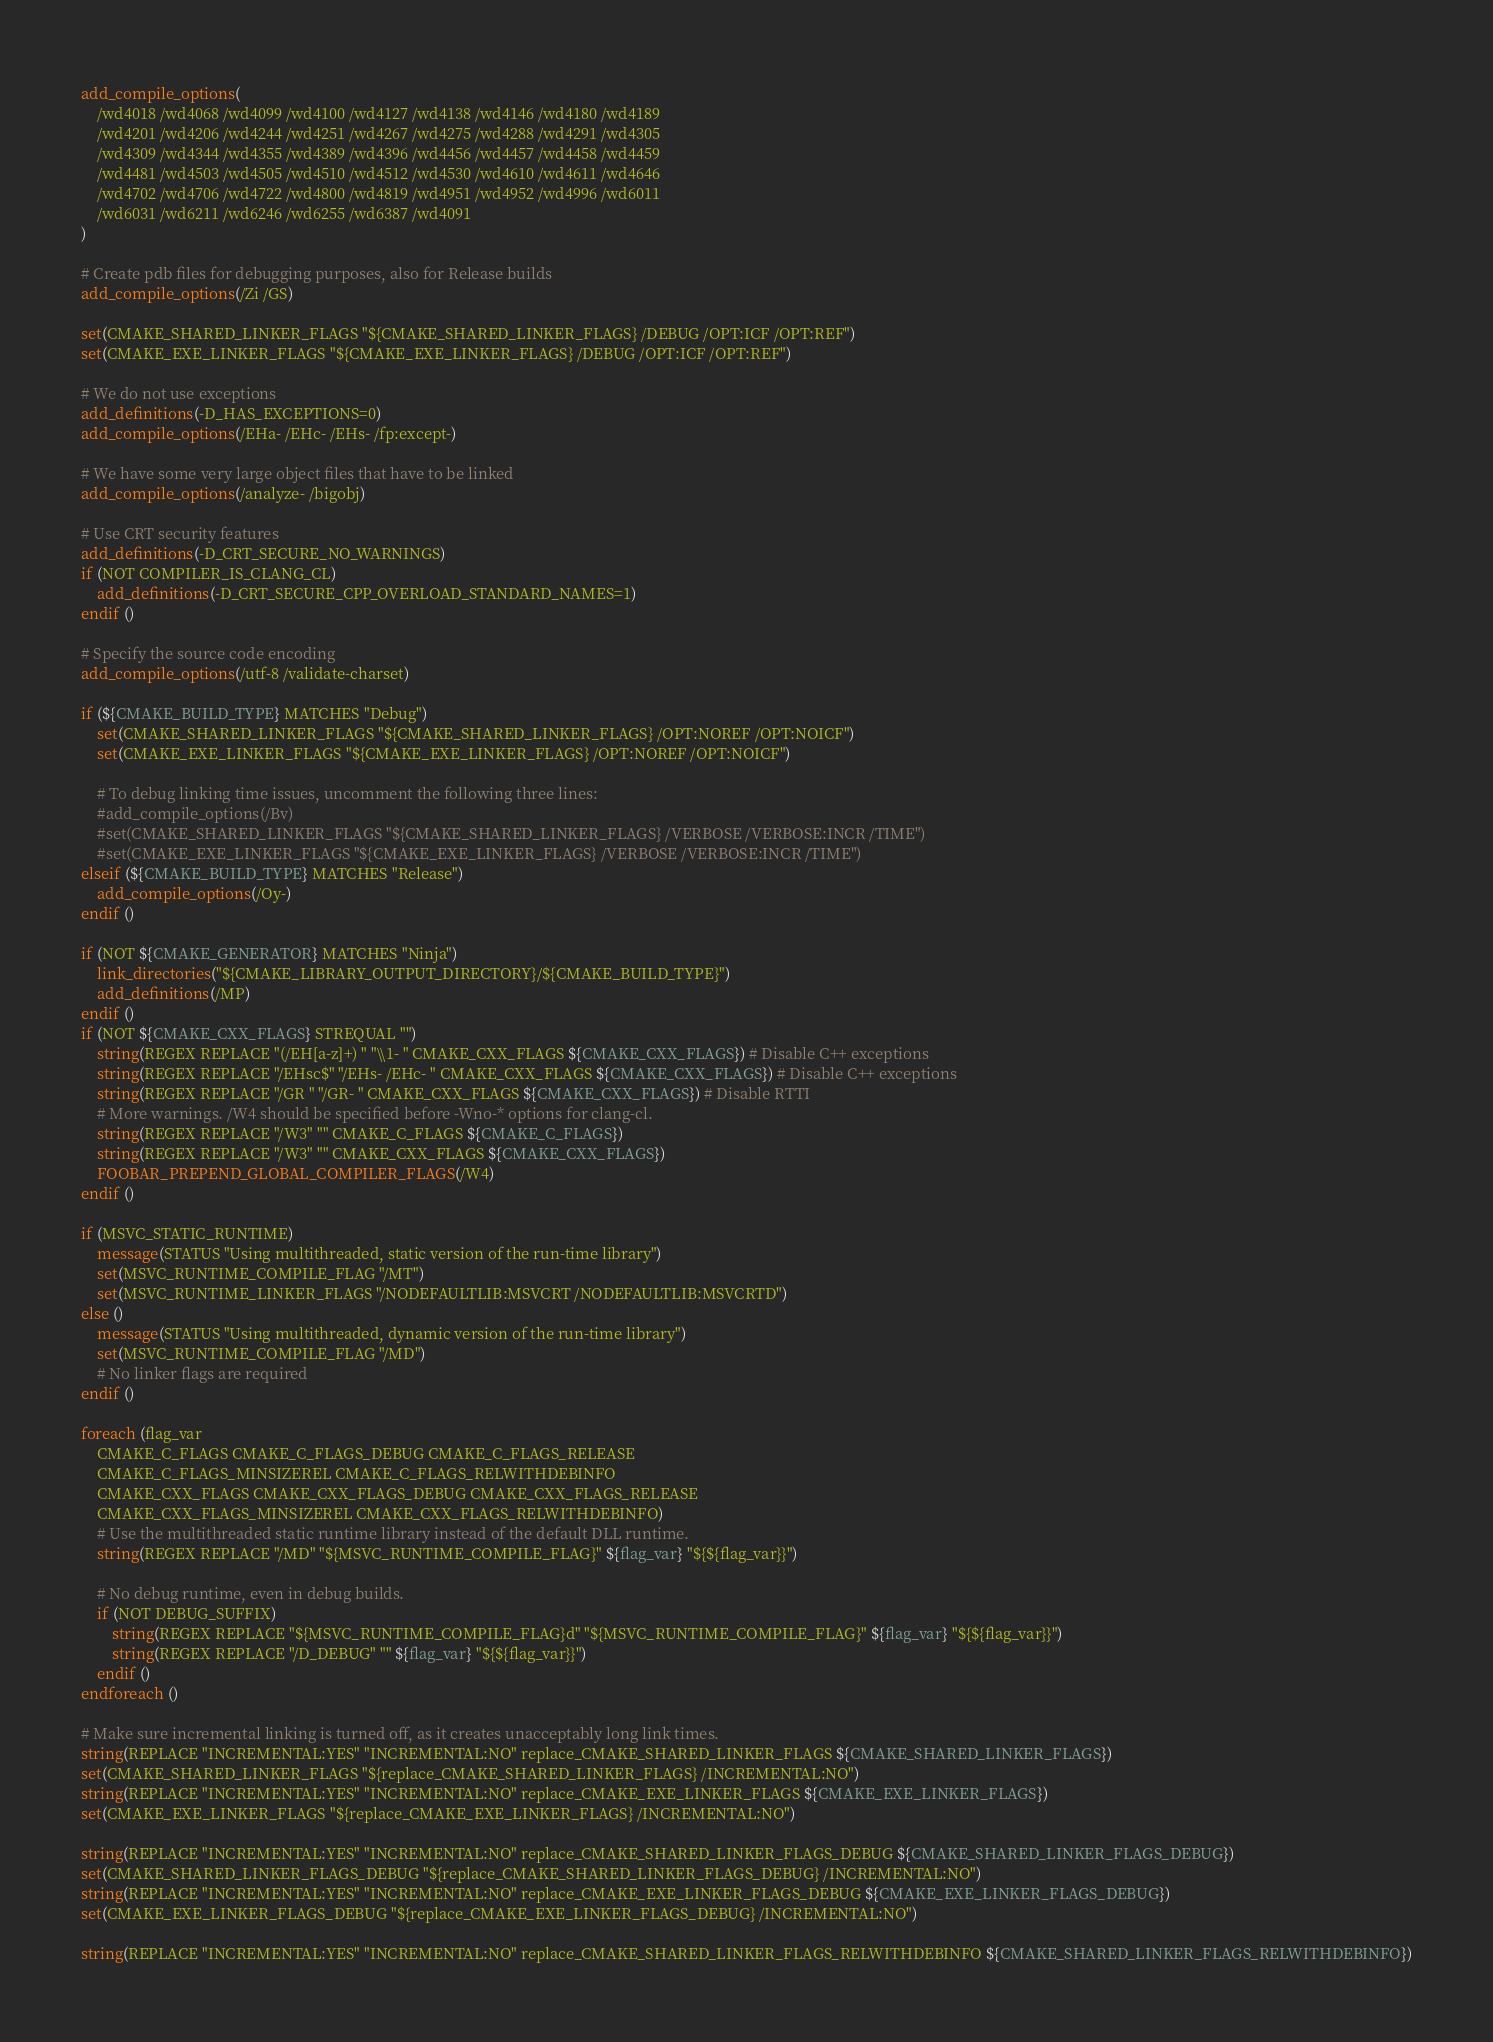Convert code to text. <code><loc_0><loc_0><loc_500><loc_500><_CMake_>add_compile_options(
    /wd4018 /wd4068 /wd4099 /wd4100 /wd4127 /wd4138 /wd4146 /wd4180 /wd4189
    /wd4201 /wd4206 /wd4244 /wd4251 /wd4267 /wd4275 /wd4288 /wd4291 /wd4305
    /wd4309 /wd4344 /wd4355 /wd4389 /wd4396 /wd4456 /wd4457 /wd4458 /wd4459
    /wd4481 /wd4503 /wd4505 /wd4510 /wd4512 /wd4530 /wd4610 /wd4611 /wd4646
    /wd4702 /wd4706 /wd4722 /wd4800 /wd4819 /wd4951 /wd4952 /wd4996 /wd6011
    /wd6031 /wd6211 /wd6246 /wd6255 /wd6387 /wd4091
)

# Create pdb files for debugging purposes, also for Release builds
add_compile_options(/Zi /GS)

set(CMAKE_SHARED_LINKER_FLAGS "${CMAKE_SHARED_LINKER_FLAGS} /DEBUG /OPT:ICF /OPT:REF")
set(CMAKE_EXE_LINKER_FLAGS "${CMAKE_EXE_LINKER_FLAGS} /DEBUG /OPT:ICF /OPT:REF")

# We do not use exceptions
add_definitions(-D_HAS_EXCEPTIONS=0)
add_compile_options(/EHa- /EHc- /EHs- /fp:except-)

# We have some very large object files that have to be linked
add_compile_options(/analyze- /bigobj)

# Use CRT security features
add_definitions(-D_CRT_SECURE_NO_WARNINGS)
if (NOT COMPILER_IS_CLANG_CL)
    add_definitions(-D_CRT_SECURE_CPP_OVERLOAD_STANDARD_NAMES=1)
endif ()

# Specify the source code encoding
add_compile_options(/utf-8 /validate-charset)

if (${CMAKE_BUILD_TYPE} MATCHES "Debug")
    set(CMAKE_SHARED_LINKER_FLAGS "${CMAKE_SHARED_LINKER_FLAGS} /OPT:NOREF /OPT:NOICF")
    set(CMAKE_EXE_LINKER_FLAGS "${CMAKE_EXE_LINKER_FLAGS} /OPT:NOREF /OPT:NOICF")

    # To debug linking time issues, uncomment the following three lines:
    #add_compile_options(/Bv)
    #set(CMAKE_SHARED_LINKER_FLAGS "${CMAKE_SHARED_LINKER_FLAGS} /VERBOSE /VERBOSE:INCR /TIME")
    #set(CMAKE_EXE_LINKER_FLAGS "${CMAKE_EXE_LINKER_FLAGS} /VERBOSE /VERBOSE:INCR /TIME")
elseif (${CMAKE_BUILD_TYPE} MATCHES "Release")
    add_compile_options(/Oy-)
endif ()

if (NOT ${CMAKE_GENERATOR} MATCHES "Ninja")
    link_directories("${CMAKE_LIBRARY_OUTPUT_DIRECTORY}/${CMAKE_BUILD_TYPE}")
    add_definitions(/MP)
endif ()
if (NOT ${CMAKE_CXX_FLAGS} STREQUAL "")
    string(REGEX REPLACE "(/EH[a-z]+) " "\\1- " CMAKE_CXX_FLAGS ${CMAKE_CXX_FLAGS}) # Disable C++ exceptions
    string(REGEX REPLACE "/EHsc$" "/EHs- /EHc- " CMAKE_CXX_FLAGS ${CMAKE_CXX_FLAGS}) # Disable C++ exceptions
    string(REGEX REPLACE "/GR " "/GR- " CMAKE_CXX_FLAGS ${CMAKE_CXX_FLAGS}) # Disable RTTI
    # More warnings. /W4 should be specified before -Wno-* options for clang-cl.
    string(REGEX REPLACE "/W3" "" CMAKE_C_FLAGS ${CMAKE_C_FLAGS})
    string(REGEX REPLACE "/W3" "" CMAKE_CXX_FLAGS ${CMAKE_CXX_FLAGS})
    FOOBAR_PREPEND_GLOBAL_COMPILER_FLAGS(/W4)
endif ()

if (MSVC_STATIC_RUNTIME)
    message(STATUS "Using multithreaded, static version of the run-time library")
    set(MSVC_RUNTIME_COMPILE_FLAG "/MT")
    set(MSVC_RUNTIME_LINKER_FLAGS "/NODEFAULTLIB:MSVCRT /NODEFAULTLIB:MSVCRTD")
else ()
    message(STATUS "Using multithreaded, dynamic version of the run-time library")
    set(MSVC_RUNTIME_COMPILE_FLAG "/MD")
    # No linker flags are required
endif ()

foreach (flag_var
    CMAKE_C_FLAGS CMAKE_C_FLAGS_DEBUG CMAKE_C_FLAGS_RELEASE
    CMAKE_C_FLAGS_MINSIZEREL CMAKE_C_FLAGS_RELWITHDEBINFO
    CMAKE_CXX_FLAGS CMAKE_CXX_FLAGS_DEBUG CMAKE_CXX_FLAGS_RELEASE
    CMAKE_CXX_FLAGS_MINSIZEREL CMAKE_CXX_FLAGS_RELWITHDEBINFO)
    # Use the multithreaded static runtime library instead of the default DLL runtime.
    string(REGEX REPLACE "/MD" "${MSVC_RUNTIME_COMPILE_FLAG}" ${flag_var} "${${flag_var}}")

    # No debug runtime, even in debug builds.
    if (NOT DEBUG_SUFFIX)
        string(REGEX REPLACE "${MSVC_RUNTIME_COMPILE_FLAG}d" "${MSVC_RUNTIME_COMPILE_FLAG}" ${flag_var} "${${flag_var}}")
        string(REGEX REPLACE "/D_DEBUG" "" ${flag_var} "${${flag_var}}")
    endif ()
endforeach ()

# Make sure incremental linking is turned off, as it creates unacceptably long link times.
string(REPLACE "INCREMENTAL:YES" "INCREMENTAL:NO" replace_CMAKE_SHARED_LINKER_FLAGS ${CMAKE_SHARED_LINKER_FLAGS})
set(CMAKE_SHARED_LINKER_FLAGS "${replace_CMAKE_SHARED_LINKER_FLAGS} /INCREMENTAL:NO")
string(REPLACE "INCREMENTAL:YES" "INCREMENTAL:NO" replace_CMAKE_EXE_LINKER_FLAGS ${CMAKE_EXE_LINKER_FLAGS})
set(CMAKE_EXE_LINKER_FLAGS "${replace_CMAKE_EXE_LINKER_FLAGS} /INCREMENTAL:NO")

string(REPLACE "INCREMENTAL:YES" "INCREMENTAL:NO" replace_CMAKE_SHARED_LINKER_FLAGS_DEBUG ${CMAKE_SHARED_LINKER_FLAGS_DEBUG})
set(CMAKE_SHARED_LINKER_FLAGS_DEBUG "${replace_CMAKE_SHARED_LINKER_FLAGS_DEBUG} /INCREMENTAL:NO")
string(REPLACE "INCREMENTAL:YES" "INCREMENTAL:NO" replace_CMAKE_EXE_LINKER_FLAGS_DEBUG ${CMAKE_EXE_LINKER_FLAGS_DEBUG})
set(CMAKE_EXE_LINKER_FLAGS_DEBUG "${replace_CMAKE_EXE_LINKER_FLAGS_DEBUG} /INCREMENTAL:NO")

string(REPLACE "INCREMENTAL:YES" "INCREMENTAL:NO" replace_CMAKE_SHARED_LINKER_FLAGS_RELWITHDEBINFO ${CMAKE_SHARED_LINKER_FLAGS_RELWITHDEBINFO})</code> 